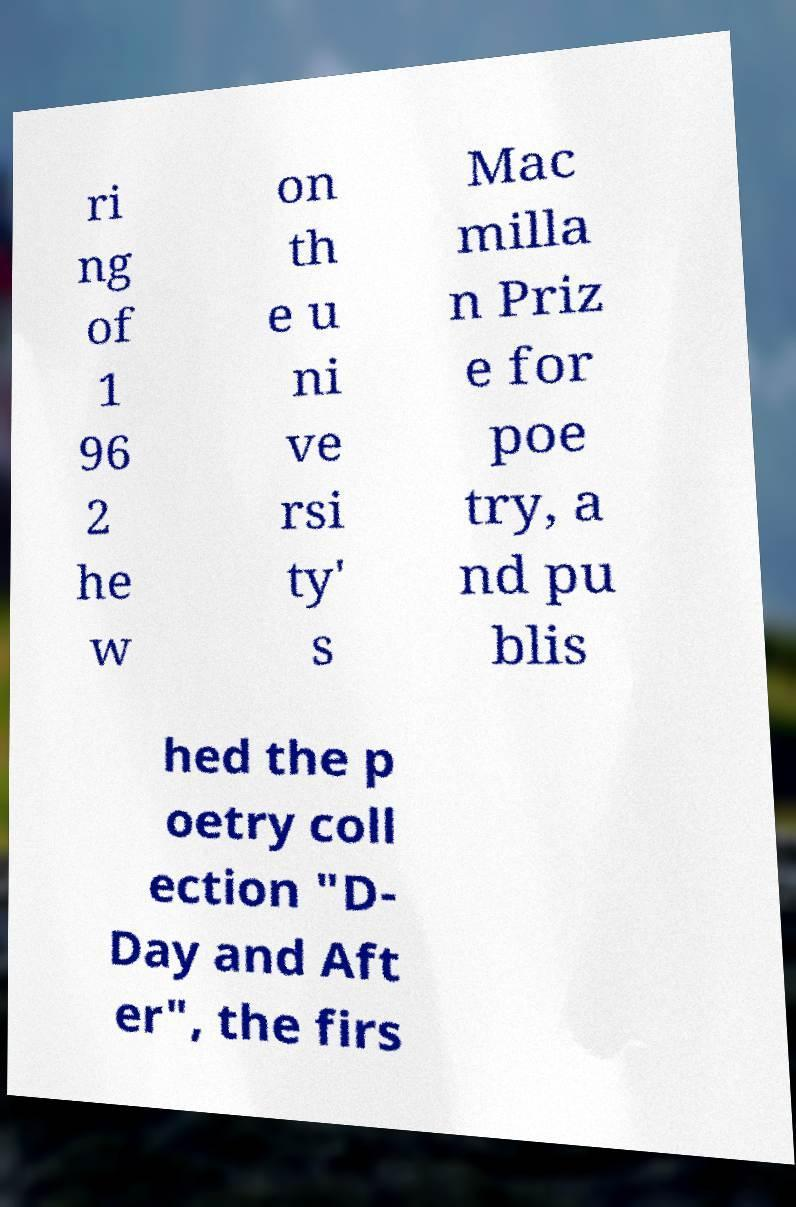I need the written content from this picture converted into text. Can you do that? ri ng of 1 96 2 he w on th e u ni ve rsi ty' s Mac milla n Priz e for poe try, a nd pu blis hed the p oetry coll ection "D- Day and Aft er", the firs 